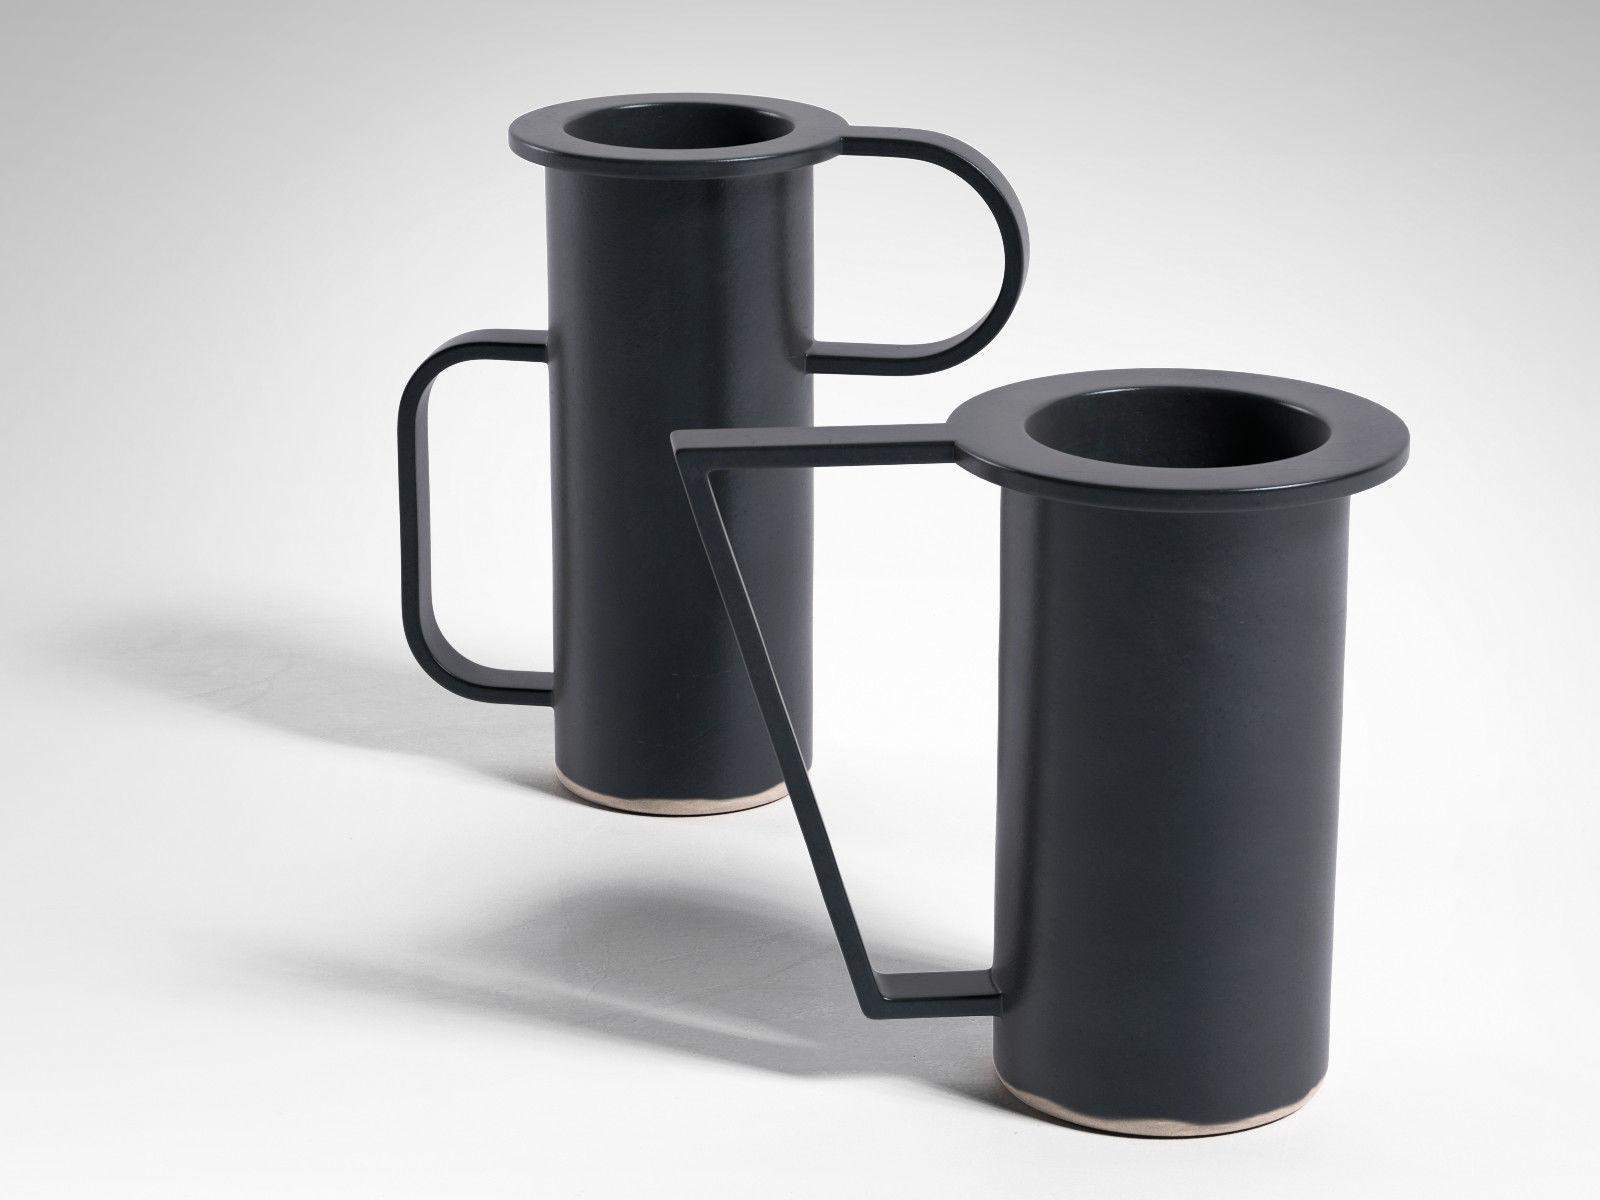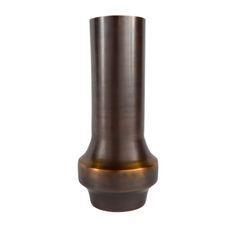The first image is the image on the left, the second image is the image on the right. For the images displayed, is the sentence "the hole in the top of the vase is visible" factually correct? Answer yes or no. Yes. The first image is the image on the left, the second image is the image on the right. Examine the images to the left and right. Is the description "Each image contains one container, and each container is curvy." accurate? Answer yes or no. No. 